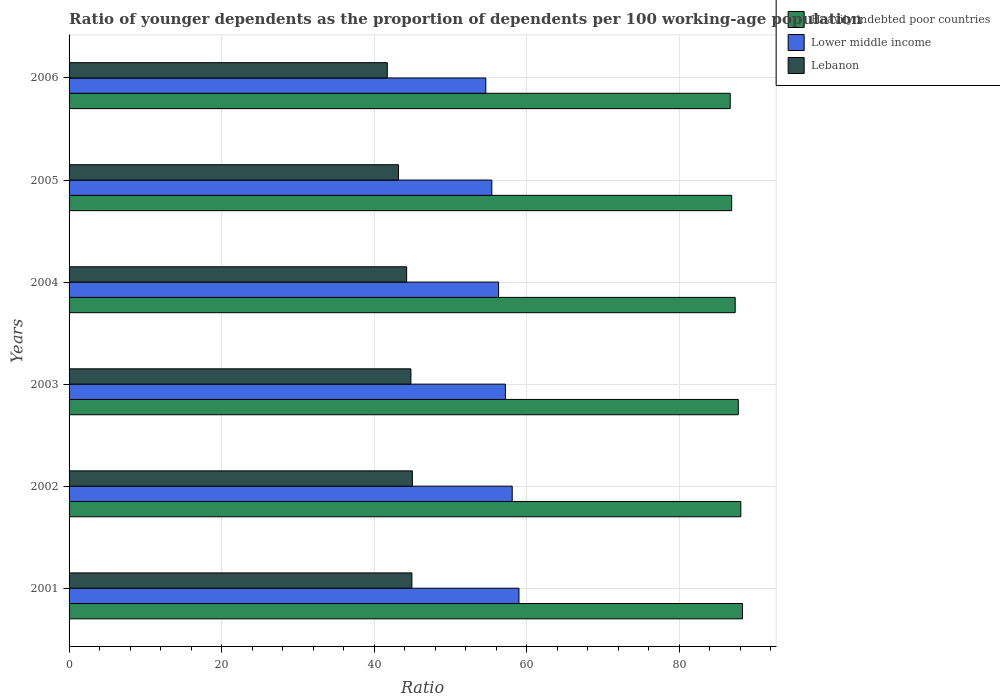Are the number of bars on each tick of the Y-axis equal?
Make the answer very short. Yes. How many bars are there on the 5th tick from the top?
Your answer should be compact. 3. In how many cases, is the number of bars for a given year not equal to the number of legend labels?
Make the answer very short. 0. What is the age dependency ratio(young) in Lebanon in 2004?
Provide a short and direct response. 44.25. Across all years, what is the maximum age dependency ratio(young) in Lower middle income?
Provide a succinct answer. 58.97. Across all years, what is the minimum age dependency ratio(young) in Lebanon?
Your answer should be compact. 41.71. What is the total age dependency ratio(young) in Lower middle income in the graph?
Your answer should be very brief. 340.58. What is the difference between the age dependency ratio(young) in Lebanon in 2002 and that in 2006?
Offer a terse response. 3.29. What is the difference between the age dependency ratio(young) in Heavily indebted poor countries in 2006 and the age dependency ratio(young) in Lower middle income in 2002?
Keep it short and to the point. 28.57. What is the average age dependency ratio(young) in Lebanon per year?
Your answer should be compact. 43.98. In the year 2005, what is the difference between the age dependency ratio(young) in Lebanon and age dependency ratio(young) in Lower middle income?
Your answer should be compact. -12.23. What is the ratio of the age dependency ratio(young) in Heavily indebted poor countries in 2001 to that in 2005?
Your answer should be very brief. 1.02. Is the age dependency ratio(young) in Lebanon in 2003 less than that in 2004?
Offer a terse response. No. What is the difference between the highest and the second highest age dependency ratio(young) in Lower middle income?
Your answer should be compact. 0.88. What is the difference between the highest and the lowest age dependency ratio(young) in Lower middle income?
Ensure brevity in your answer.  4.35. In how many years, is the age dependency ratio(young) in Lower middle income greater than the average age dependency ratio(young) in Lower middle income taken over all years?
Provide a short and direct response. 3. Is the sum of the age dependency ratio(young) in Heavily indebted poor countries in 2001 and 2005 greater than the maximum age dependency ratio(young) in Lower middle income across all years?
Ensure brevity in your answer.  Yes. What does the 3rd bar from the top in 2002 represents?
Keep it short and to the point. Heavily indebted poor countries. What does the 2nd bar from the bottom in 2006 represents?
Provide a short and direct response. Lower middle income. Is it the case that in every year, the sum of the age dependency ratio(young) in Heavily indebted poor countries and age dependency ratio(young) in Lebanon is greater than the age dependency ratio(young) in Lower middle income?
Your response must be concise. Yes. How many years are there in the graph?
Provide a short and direct response. 6. What is the difference between two consecutive major ticks on the X-axis?
Ensure brevity in your answer.  20. Are the values on the major ticks of X-axis written in scientific E-notation?
Provide a succinct answer. No. What is the title of the graph?
Make the answer very short. Ratio of younger dependents as the proportion of dependents per 100 working-age population. What is the label or title of the X-axis?
Keep it short and to the point. Ratio. What is the Ratio of Heavily indebted poor countries in 2001?
Keep it short and to the point. 88.27. What is the Ratio in Lower middle income in 2001?
Your response must be concise. 58.97. What is the Ratio of Lebanon in 2001?
Make the answer very short. 44.93. What is the Ratio of Heavily indebted poor countries in 2002?
Keep it short and to the point. 88.05. What is the Ratio in Lower middle income in 2002?
Your response must be concise. 58.09. What is the Ratio of Lebanon in 2002?
Ensure brevity in your answer.  45. What is the Ratio of Heavily indebted poor countries in 2003?
Give a very brief answer. 87.72. What is the Ratio of Lower middle income in 2003?
Keep it short and to the point. 57.19. What is the Ratio of Lebanon in 2003?
Your response must be concise. 44.81. What is the Ratio of Heavily indebted poor countries in 2004?
Keep it short and to the point. 87.31. What is the Ratio of Lower middle income in 2004?
Your answer should be very brief. 56.3. What is the Ratio of Lebanon in 2004?
Offer a very short reply. 44.25. What is the Ratio in Heavily indebted poor countries in 2005?
Provide a succinct answer. 86.85. What is the Ratio of Lower middle income in 2005?
Offer a terse response. 55.41. What is the Ratio of Lebanon in 2005?
Provide a succinct answer. 43.18. What is the Ratio of Heavily indebted poor countries in 2006?
Offer a very short reply. 86.66. What is the Ratio in Lower middle income in 2006?
Your answer should be compact. 54.62. What is the Ratio in Lebanon in 2006?
Give a very brief answer. 41.71. Across all years, what is the maximum Ratio in Heavily indebted poor countries?
Give a very brief answer. 88.27. Across all years, what is the maximum Ratio of Lower middle income?
Your response must be concise. 58.97. Across all years, what is the maximum Ratio of Lebanon?
Your answer should be compact. 45. Across all years, what is the minimum Ratio in Heavily indebted poor countries?
Offer a terse response. 86.66. Across all years, what is the minimum Ratio in Lower middle income?
Give a very brief answer. 54.62. Across all years, what is the minimum Ratio of Lebanon?
Your answer should be very brief. 41.71. What is the total Ratio of Heavily indebted poor countries in the graph?
Provide a short and direct response. 524.85. What is the total Ratio in Lower middle income in the graph?
Keep it short and to the point. 340.58. What is the total Ratio of Lebanon in the graph?
Provide a succinct answer. 263.87. What is the difference between the Ratio in Heavily indebted poor countries in 2001 and that in 2002?
Offer a terse response. 0.22. What is the difference between the Ratio in Lower middle income in 2001 and that in 2002?
Provide a succinct answer. 0.88. What is the difference between the Ratio of Lebanon in 2001 and that in 2002?
Ensure brevity in your answer.  -0.06. What is the difference between the Ratio of Heavily indebted poor countries in 2001 and that in 2003?
Ensure brevity in your answer.  0.55. What is the difference between the Ratio in Lower middle income in 2001 and that in 2003?
Provide a short and direct response. 1.78. What is the difference between the Ratio of Lebanon in 2001 and that in 2003?
Give a very brief answer. 0.13. What is the difference between the Ratio in Heavily indebted poor countries in 2001 and that in 2004?
Make the answer very short. 0.95. What is the difference between the Ratio in Lower middle income in 2001 and that in 2004?
Offer a very short reply. 2.68. What is the difference between the Ratio of Lebanon in 2001 and that in 2004?
Your response must be concise. 0.69. What is the difference between the Ratio in Heavily indebted poor countries in 2001 and that in 2005?
Provide a short and direct response. 1.42. What is the difference between the Ratio in Lower middle income in 2001 and that in 2005?
Ensure brevity in your answer.  3.56. What is the difference between the Ratio in Lebanon in 2001 and that in 2005?
Offer a terse response. 1.75. What is the difference between the Ratio of Heavily indebted poor countries in 2001 and that in 2006?
Give a very brief answer. 1.61. What is the difference between the Ratio in Lower middle income in 2001 and that in 2006?
Your answer should be compact. 4.35. What is the difference between the Ratio in Lebanon in 2001 and that in 2006?
Offer a terse response. 3.22. What is the difference between the Ratio in Heavily indebted poor countries in 2002 and that in 2003?
Provide a short and direct response. 0.33. What is the difference between the Ratio of Lower middle income in 2002 and that in 2003?
Your answer should be very brief. 0.9. What is the difference between the Ratio in Lebanon in 2002 and that in 2003?
Provide a short and direct response. 0.19. What is the difference between the Ratio in Heavily indebted poor countries in 2002 and that in 2004?
Your response must be concise. 0.73. What is the difference between the Ratio in Lower middle income in 2002 and that in 2004?
Your response must be concise. 1.79. What is the difference between the Ratio of Lebanon in 2002 and that in 2004?
Your answer should be very brief. 0.75. What is the difference between the Ratio of Heavily indebted poor countries in 2002 and that in 2005?
Your response must be concise. 1.2. What is the difference between the Ratio of Lower middle income in 2002 and that in 2005?
Keep it short and to the point. 2.67. What is the difference between the Ratio in Lebanon in 2002 and that in 2005?
Your answer should be compact. 1.82. What is the difference between the Ratio of Heavily indebted poor countries in 2002 and that in 2006?
Give a very brief answer. 1.39. What is the difference between the Ratio of Lower middle income in 2002 and that in 2006?
Give a very brief answer. 3.46. What is the difference between the Ratio of Lebanon in 2002 and that in 2006?
Offer a terse response. 3.29. What is the difference between the Ratio in Heavily indebted poor countries in 2003 and that in 2004?
Provide a short and direct response. 0.4. What is the difference between the Ratio in Lower middle income in 2003 and that in 2004?
Your answer should be very brief. 0.89. What is the difference between the Ratio in Lebanon in 2003 and that in 2004?
Give a very brief answer. 0.56. What is the difference between the Ratio of Heavily indebted poor countries in 2003 and that in 2005?
Your answer should be very brief. 0.87. What is the difference between the Ratio of Lower middle income in 2003 and that in 2005?
Offer a terse response. 1.78. What is the difference between the Ratio of Lebanon in 2003 and that in 2005?
Provide a short and direct response. 1.62. What is the difference between the Ratio of Heavily indebted poor countries in 2003 and that in 2006?
Keep it short and to the point. 1.06. What is the difference between the Ratio of Lower middle income in 2003 and that in 2006?
Your response must be concise. 2.57. What is the difference between the Ratio of Lebanon in 2003 and that in 2006?
Your answer should be very brief. 3.1. What is the difference between the Ratio in Heavily indebted poor countries in 2004 and that in 2005?
Provide a succinct answer. 0.46. What is the difference between the Ratio in Lower middle income in 2004 and that in 2005?
Ensure brevity in your answer.  0.88. What is the difference between the Ratio of Lebanon in 2004 and that in 2005?
Give a very brief answer. 1.07. What is the difference between the Ratio of Heavily indebted poor countries in 2004 and that in 2006?
Provide a short and direct response. 0.65. What is the difference between the Ratio of Lower middle income in 2004 and that in 2006?
Keep it short and to the point. 1.67. What is the difference between the Ratio of Lebanon in 2004 and that in 2006?
Offer a terse response. 2.54. What is the difference between the Ratio in Heavily indebted poor countries in 2005 and that in 2006?
Provide a succinct answer. 0.19. What is the difference between the Ratio of Lower middle income in 2005 and that in 2006?
Your answer should be very brief. 0.79. What is the difference between the Ratio of Lebanon in 2005 and that in 2006?
Offer a terse response. 1.47. What is the difference between the Ratio in Heavily indebted poor countries in 2001 and the Ratio in Lower middle income in 2002?
Your answer should be very brief. 30.18. What is the difference between the Ratio in Heavily indebted poor countries in 2001 and the Ratio in Lebanon in 2002?
Offer a very short reply. 43.27. What is the difference between the Ratio of Lower middle income in 2001 and the Ratio of Lebanon in 2002?
Give a very brief answer. 13.97. What is the difference between the Ratio in Heavily indebted poor countries in 2001 and the Ratio in Lower middle income in 2003?
Your answer should be very brief. 31.08. What is the difference between the Ratio of Heavily indebted poor countries in 2001 and the Ratio of Lebanon in 2003?
Give a very brief answer. 43.46. What is the difference between the Ratio of Lower middle income in 2001 and the Ratio of Lebanon in 2003?
Keep it short and to the point. 14.17. What is the difference between the Ratio of Heavily indebted poor countries in 2001 and the Ratio of Lower middle income in 2004?
Provide a succinct answer. 31.97. What is the difference between the Ratio of Heavily indebted poor countries in 2001 and the Ratio of Lebanon in 2004?
Offer a very short reply. 44.02. What is the difference between the Ratio of Lower middle income in 2001 and the Ratio of Lebanon in 2004?
Ensure brevity in your answer.  14.72. What is the difference between the Ratio in Heavily indebted poor countries in 2001 and the Ratio in Lower middle income in 2005?
Ensure brevity in your answer.  32.85. What is the difference between the Ratio in Heavily indebted poor countries in 2001 and the Ratio in Lebanon in 2005?
Make the answer very short. 45.09. What is the difference between the Ratio of Lower middle income in 2001 and the Ratio of Lebanon in 2005?
Your answer should be compact. 15.79. What is the difference between the Ratio in Heavily indebted poor countries in 2001 and the Ratio in Lower middle income in 2006?
Make the answer very short. 33.65. What is the difference between the Ratio of Heavily indebted poor countries in 2001 and the Ratio of Lebanon in 2006?
Give a very brief answer. 46.56. What is the difference between the Ratio in Lower middle income in 2001 and the Ratio in Lebanon in 2006?
Offer a terse response. 17.26. What is the difference between the Ratio of Heavily indebted poor countries in 2002 and the Ratio of Lower middle income in 2003?
Offer a very short reply. 30.86. What is the difference between the Ratio in Heavily indebted poor countries in 2002 and the Ratio in Lebanon in 2003?
Ensure brevity in your answer.  43.24. What is the difference between the Ratio in Lower middle income in 2002 and the Ratio in Lebanon in 2003?
Your answer should be compact. 13.28. What is the difference between the Ratio of Heavily indebted poor countries in 2002 and the Ratio of Lower middle income in 2004?
Make the answer very short. 31.75. What is the difference between the Ratio in Heavily indebted poor countries in 2002 and the Ratio in Lebanon in 2004?
Give a very brief answer. 43.8. What is the difference between the Ratio of Lower middle income in 2002 and the Ratio of Lebanon in 2004?
Offer a very short reply. 13.84. What is the difference between the Ratio in Heavily indebted poor countries in 2002 and the Ratio in Lower middle income in 2005?
Make the answer very short. 32.64. What is the difference between the Ratio of Heavily indebted poor countries in 2002 and the Ratio of Lebanon in 2005?
Your answer should be compact. 44.87. What is the difference between the Ratio in Lower middle income in 2002 and the Ratio in Lebanon in 2005?
Offer a very short reply. 14.91. What is the difference between the Ratio of Heavily indebted poor countries in 2002 and the Ratio of Lower middle income in 2006?
Your answer should be very brief. 33.43. What is the difference between the Ratio of Heavily indebted poor countries in 2002 and the Ratio of Lebanon in 2006?
Your answer should be very brief. 46.34. What is the difference between the Ratio in Lower middle income in 2002 and the Ratio in Lebanon in 2006?
Provide a short and direct response. 16.38. What is the difference between the Ratio of Heavily indebted poor countries in 2003 and the Ratio of Lower middle income in 2004?
Your response must be concise. 31.42. What is the difference between the Ratio in Heavily indebted poor countries in 2003 and the Ratio in Lebanon in 2004?
Offer a terse response. 43.47. What is the difference between the Ratio of Lower middle income in 2003 and the Ratio of Lebanon in 2004?
Your answer should be very brief. 12.94. What is the difference between the Ratio in Heavily indebted poor countries in 2003 and the Ratio in Lower middle income in 2005?
Make the answer very short. 32.3. What is the difference between the Ratio in Heavily indebted poor countries in 2003 and the Ratio in Lebanon in 2005?
Make the answer very short. 44.54. What is the difference between the Ratio in Lower middle income in 2003 and the Ratio in Lebanon in 2005?
Make the answer very short. 14.01. What is the difference between the Ratio in Heavily indebted poor countries in 2003 and the Ratio in Lower middle income in 2006?
Provide a succinct answer. 33.1. What is the difference between the Ratio of Heavily indebted poor countries in 2003 and the Ratio of Lebanon in 2006?
Provide a succinct answer. 46.01. What is the difference between the Ratio in Lower middle income in 2003 and the Ratio in Lebanon in 2006?
Offer a very short reply. 15.48. What is the difference between the Ratio in Heavily indebted poor countries in 2004 and the Ratio in Lower middle income in 2005?
Make the answer very short. 31.9. What is the difference between the Ratio of Heavily indebted poor countries in 2004 and the Ratio of Lebanon in 2005?
Offer a terse response. 44.13. What is the difference between the Ratio in Lower middle income in 2004 and the Ratio in Lebanon in 2005?
Make the answer very short. 13.11. What is the difference between the Ratio of Heavily indebted poor countries in 2004 and the Ratio of Lower middle income in 2006?
Make the answer very short. 32.69. What is the difference between the Ratio in Heavily indebted poor countries in 2004 and the Ratio in Lebanon in 2006?
Your response must be concise. 45.6. What is the difference between the Ratio of Lower middle income in 2004 and the Ratio of Lebanon in 2006?
Offer a very short reply. 14.59. What is the difference between the Ratio of Heavily indebted poor countries in 2005 and the Ratio of Lower middle income in 2006?
Provide a short and direct response. 32.23. What is the difference between the Ratio in Heavily indebted poor countries in 2005 and the Ratio in Lebanon in 2006?
Offer a terse response. 45.14. What is the difference between the Ratio of Lower middle income in 2005 and the Ratio of Lebanon in 2006?
Keep it short and to the point. 13.7. What is the average Ratio of Heavily indebted poor countries per year?
Offer a very short reply. 87.48. What is the average Ratio of Lower middle income per year?
Your response must be concise. 56.76. What is the average Ratio of Lebanon per year?
Give a very brief answer. 43.98. In the year 2001, what is the difference between the Ratio of Heavily indebted poor countries and Ratio of Lower middle income?
Make the answer very short. 29.3. In the year 2001, what is the difference between the Ratio of Heavily indebted poor countries and Ratio of Lebanon?
Keep it short and to the point. 43.33. In the year 2001, what is the difference between the Ratio in Lower middle income and Ratio in Lebanon?
Your response must be concise. 14.04. In the year 2002, what is the difference between the Ratio in Heavily indebted poor countries and Ratio in Lower middle income?
Give a very brief answer. 29.96. In the year 2002, what is the difference between the Ratio in Heavily indebted poor countries and Ratio in Lebanon?
Your answer should be very brief. 43.05. In the year 2002, what is the difference between the Ratio in Lower middle income and Ratio in Lebanon?
Make the answer very short. 13.09. In the year 2003, what is the difference between the Ratio in Heavily indebted poor countries and Ratio in Lower middle income?
Your response must be concise. 30.53. In the year 2003, what is the difference between the Ratio in Heavily indebted poor countries and Ratio in Lebanon?
Offer a very short reply. 42.91. In the year 2003, what is the difference between the Ratio of Lower middle income and Ratio of Lebanon?
Your answer should be very brief. 12.38. In the year 2004, what is the difference between the Ratio in Heavily indebted poor countries and Ratio in Lower middle income?
Make the answer very short. 31.02. In the year 2004, what is the difference between the Ratio of Heavily indebted poor countries and Ratio of Lebanon?
Keep it short and to the point. 43.07. In the year 2004, what is the difference between the Ratio of Lower middle income and Ratio of Lebanon?
Offer a very short reply. 12.05. In the year 2005, what is the difference between the Ratio in Heavily indebted poor countries and Ratio in Lower middle income?
Your response must be concise. 31.44. In the year 2005, what is the difference between the Ratio in Heavily indebted poor countries and Ratio in Lebanon?
Your answer should be very brief. 43.67. In the year 2005, what is the difference between the Ratio of Lower middle income and Ratio of Lebanon?
Offer a very short reply. 12.23. In the year 2006, what is the difference between the Ratio of Heavily indebted poor countries and Ratio of Lower middle income?
Your answer should be compact. 32.04. In the year 2006, what is the difference between the Ratio in Heavily indebted poor countries and Ratio in Lebanon?
Provide a succinct answer. 44.95. In the year 2006, what is the difference between the Ratio of Lower middle income and Ratio of Lebanon?
Make the answer very short. 12.91. What is the ratio of the Ratio in Heavily indebted poor countries in 2001 to that in 2002?
Provide a short and direct response. 1. What is the ratio of the Ratio of Lower middle income in 2001 to that in 2002?
Provide a succinct answer. 1.02. What is the ratio of the Ratio of Heavily indebted poor countries in 2001 to that in 2003?
Offer a terse response. 1.01. What is the ratio of the Ratio in Lower middle income in 2001 to that in 2003?
Offer a terse response. 1.03. What is the ratio of the Ratio of Heavily indebted poor countries in 2001 to that in 2004?
Ensure brevity in your answer.  1.01. What is the ratio of the Ratio of Lower middle income in 2001 to that in 2004?
Provide a succinct answer. 1.05. What is the ratio of the Ratio of Lebanon in 2001 to that in 2004?
Your answer should be compact. 1.02. What is the ratio of the Ratio in Heavily indebted poor countries in 2001 to that in 2005?
Offer a very short reply. 1.02. What is the ratio of the Ratio in Lower middle income in 2001 to that in 2005?
Give a very brief answer. 1.06. What is the ratio of the Ratio in Lebanon in 2001 to that in 2005?
Offer a terse response. 1.04. What is the ratio of the Ratio in Heavily indebted poor countries in 2001 to that in 2006?
Make the answer very short. 1.02. What is the ratio of the Ratio of Lower middle income in 2001 to that in 2006?
Keep it short and to the point. 1.08. What is the ratio of the Ratio of Lebanon in 2001 to that in 2006?
Offer a very short reply. 1.08. What is the ratio of the Ratio of Heavily indebted poor countries in 2002 to that in 2003?
Provide a succinct answer. 1. What is the ratio of the Ratio of Lower middle income in 2002 to that in 2003?
Ensure brevity in your answer.  1.02. What is the ratio of the Ratio in Lebanon in 2002 to that in 2003?
Your answer should be very brief. 1. What is the ratio of the Ratio in Heavily indebted poor countries in 2002 to that in 2004?
Your response must be concise. 1.01. What is the ratio of the Ratio of Lower middle income in 2002 to that in 2004?
Provide a short and direct response. 1.03. What is the ratio of the Ratio of Lebanon in 2002 to that in 2004?
Keep it short and to the point. 1.02. What is the ratio of the Ratio of Heavily indebted poor countries in 2002 to that in 2005?
Offer a terse response. 1.01. What is the ratio of the Ratio in Lower middle income in 2002 to that in 2005?
Offer a terse response. 1.05. What is the ratio of the Ratio in Lebanon in 2002 to that in 2005?
Your answer should be compact. 1.04. What is the ratio of the Ratio of Lower middle income in 2002 to that in 2006?
Offer a terse response. 1.06. What is the ratio of the Ratio in Lebanon in 2002 to that in 2006?
Offer a terse response. 1.08. What is the ratio of the Ratio in Lower middle income in 2003 to that in 2004?
Ensure brevity in your answer.  1.02. What is the ratio of the Ratio in Lebanon in 2003 to that in 2004?
Keep it short and to the point. 1.01. What is the ratio of the Ratio of Lower middle income in 2003 to that in 2005?
Provide a short and direct response. 1.03. What is the ratio of the Ratio in Lebanon in 2003 to that in 2005?
Keep it short and to the point. 1.04. What is the ratio of the Ratio in Heavily indebted poor countries in 2003 to that in 2006?
Provide a succinct answer. 1.01. What is the ratio of the Ratio in Lower middle income in 2003 to that in 2006?
Ensure brevity in your answer.  1.05. What is the ratio of the Ratio in Lebanon in 2003 to that in 2006?
Make the answer very short. 1.07. What is the ratio of the Ratio in Lower middle income in 2004 to that in 2005?
Provide a succinct answer. 1.02. What is the ratio of the Ratio of Lebanon in 2004 to that in 2005?
Give a very brief answer. 1.02. What is the ratio of the Ratio of Heavily indebted poor countries in 2004 to that in 2006?
Offer a very short reply. 1.01. What is the ratio of the Ratio in Lower middle income in 2004 to that in 2006?
Provide a short and direct response. 1.03. What is the ratio of the Ratio in Lebanon in 2004 to that in 2006?
Offer a very short reply. 1.06. What is the ratio of the Ratio in Heavily indebted poor countries in 2005 to that in 2006?
Provide a short and direct response. 1. What is the ratio of the Ratio in Lower middle income in 2005 to that in 2006?
Provide a succinct answer. 1.01. What is the ratio of the Ratio of Lebanon in 2005 to that in 2006?
Make the answer very short. 1.04. What is the difference between the highest and the second highest Ratio of Heavily indebted poor countries?
Provide a succinct answer. 0.22. What is the difference between the highest and the second highest Ratio in Lower middle income?
Ensure brevity in your answer.  0.88. What is the difference between the highest and the second highest Ratio of Lebanon?
Your response must be concise. 0.06. What is the difference between the highest and the lowest Ratio of Heavily indebted poor countries?
Your answer should be very brief. 1.61. What is the difference between the highest and the lowest Ratio in Lower middle income?
Your answer should be compact. 4.35. What is the difference between the highest and the lowest Ratio in Lebanon?
Provide a short and direct response. 3.29. 